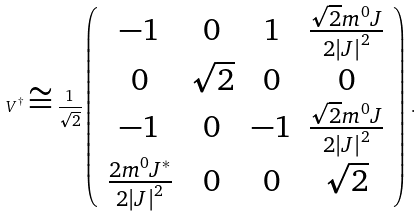Convert formula to latex. <formula><loc_0><loc_0><loc_500><loc_500>V ^ { \dagger } \cong \frac { 1 } { \sqrt { 2 } } \left ( \begin{array} { c c c c } - 1 & 0 & 1 & \frac { \sqrt { 2 } m ^ { 0 } J } { 2 \left | J \right | ^ { 2 } } \\ 0 & \sqrt { 2 } & 0 & 0 \\ - 1 & 0 & - 1 & \frac { \sqrt { 2 } m ^ { 0 } J } { 2 \left | J \right | ^ { 2 } } \\ \frac { 2 m ^ { 0 } J ^ { \ast } } { 2 \left | J \right | ^ { 2 } } & 0 & 0 & \sqrt { 2 } \end{array} \right ) \, .</formula> 